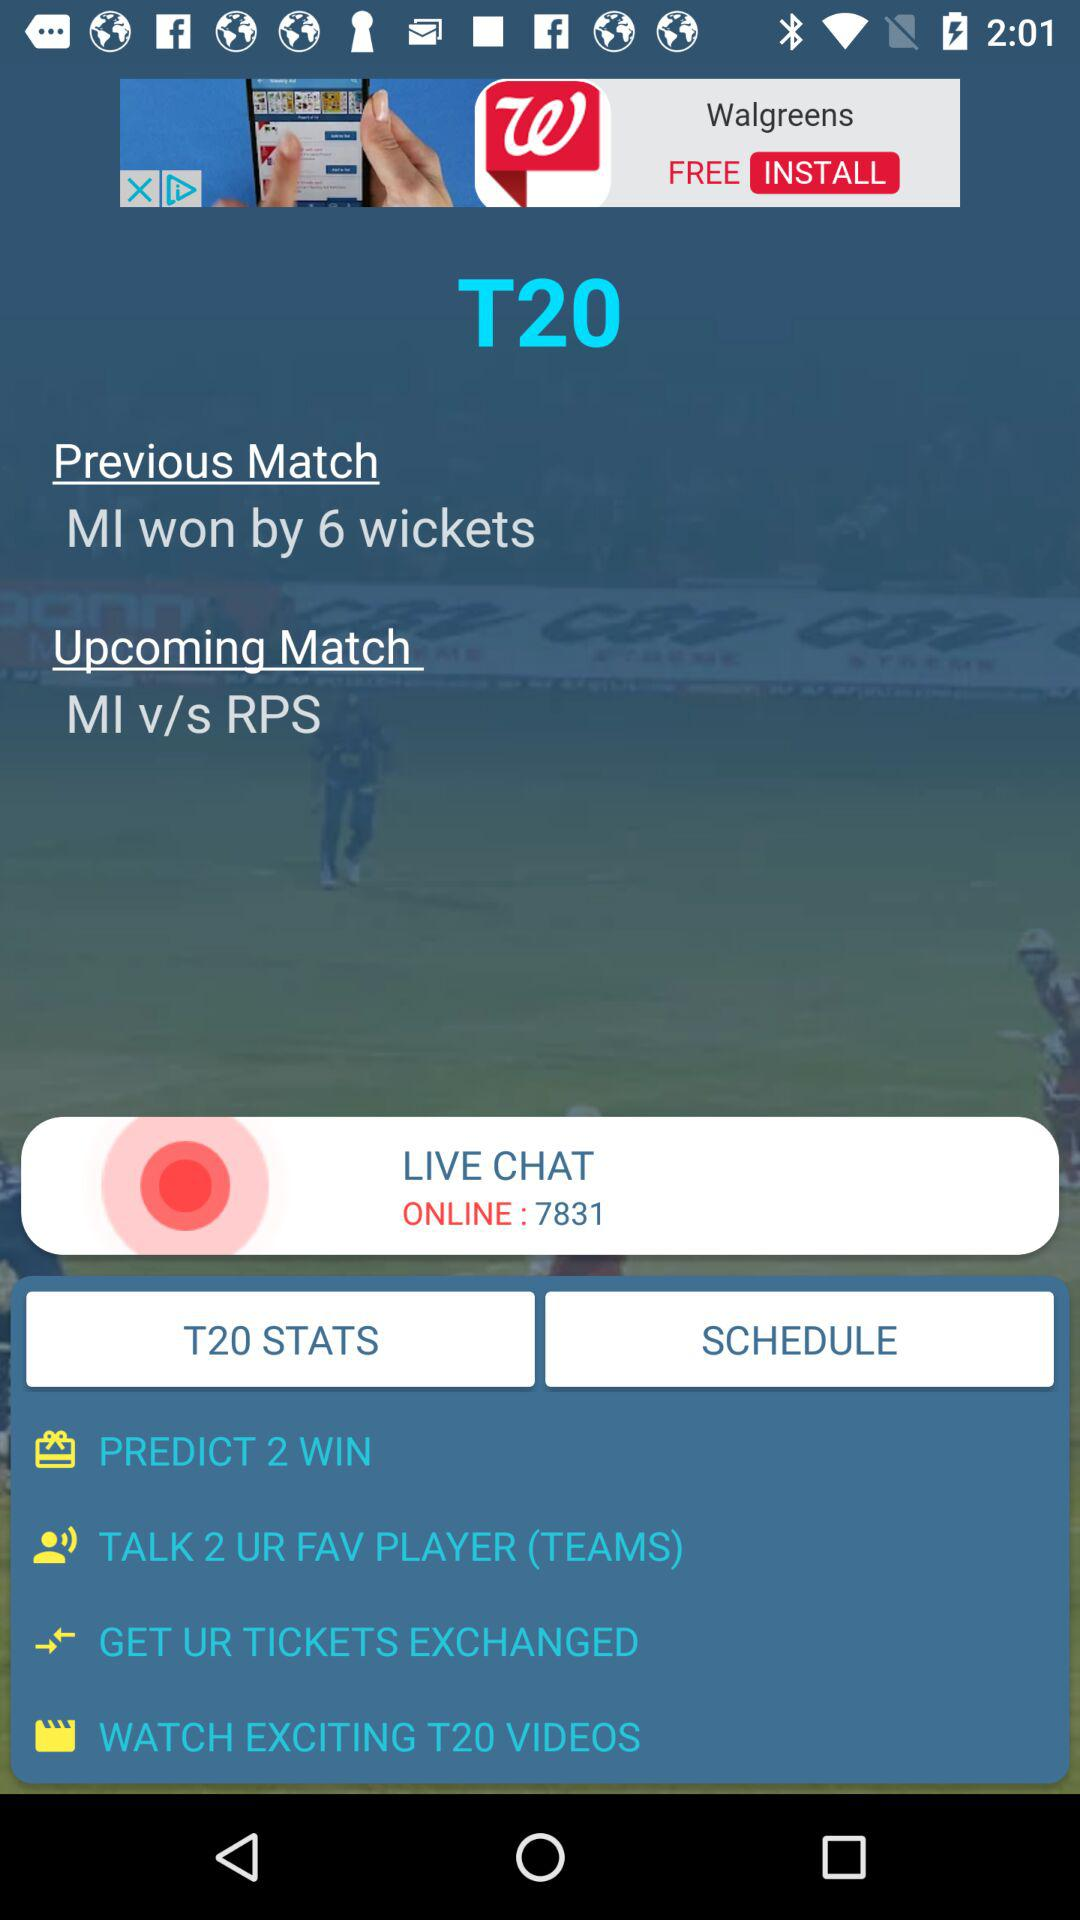What is the name of the application in the advertisement? The name of the application is "Walgreens". 